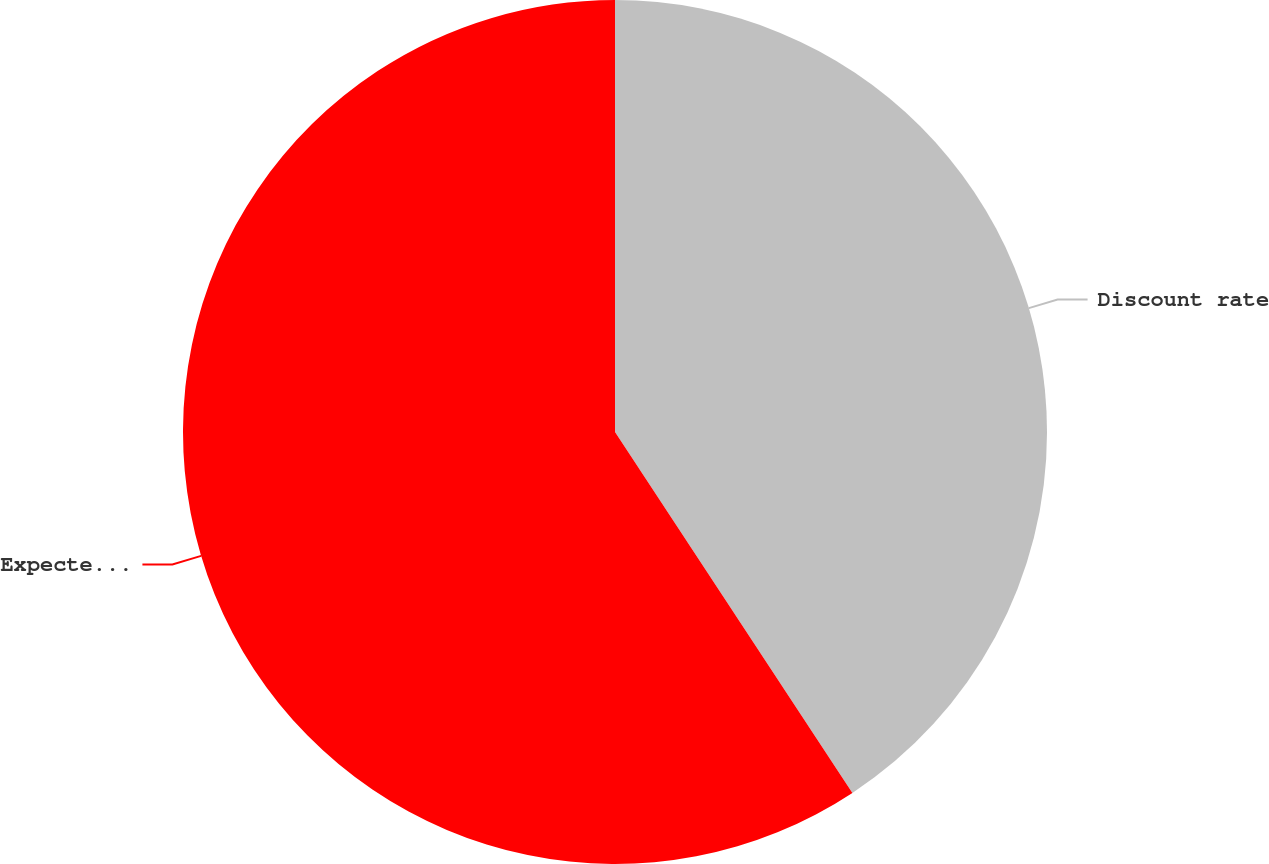<chart> <loc_0><loc_0><loc_500><loc_500><pie_chart><fcel>Discount rate<fcel>Expected return on plan assets<nl><fcel>40.74%<fcel>59.26%<nl></chart> 